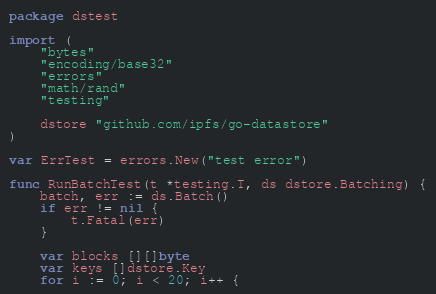<code> <loc_0><loc_0><loc_500><loc_500><_Go_>package dstest

import (
	"bytes"
	"encoding/base32"
	"errors"
	"math/rand"
	"testing"

	dstore "github.com/ipfs/go-datastore"
)

var ErrTest = errors.New("test error")

func RunBatchTest(t *testing.T, ds dstore.Batching) {
	batch, err := ds.Batch()
	if err != nil {
		t.Fatal(err)
	}

	var blocks [][]byte
	var keys []dstore.Key
	for i := 0; i < 20; i++ {</code> 